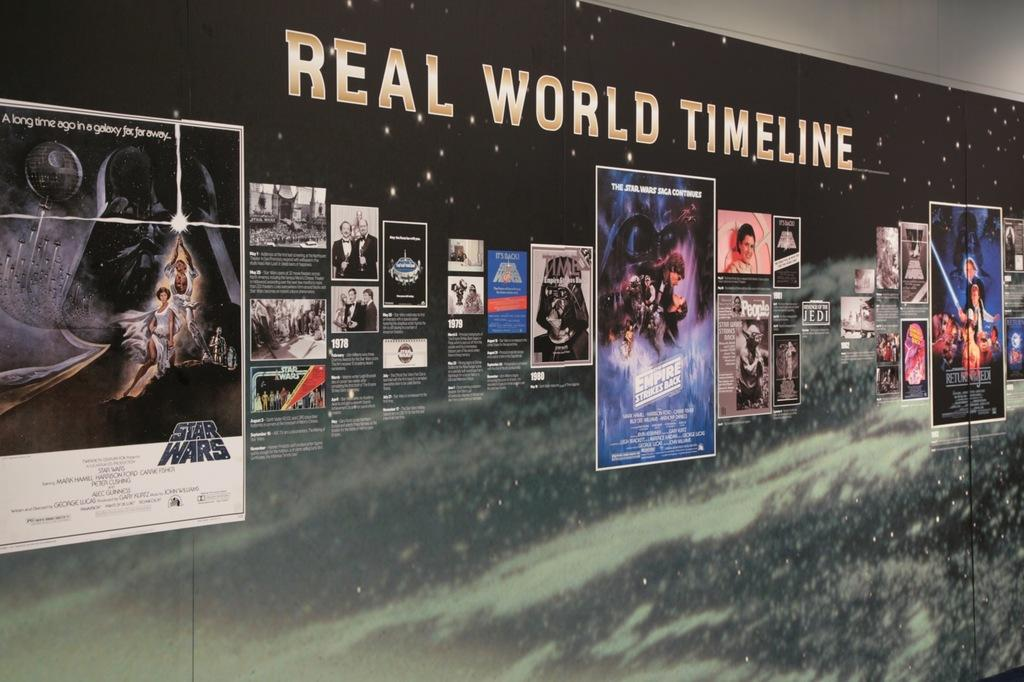Provide a one-sentence caption for the provided image. A poster featuring "Star Wars" movie art called "Real World Timeline" shows different Star Wars movie posters alongside each other. 